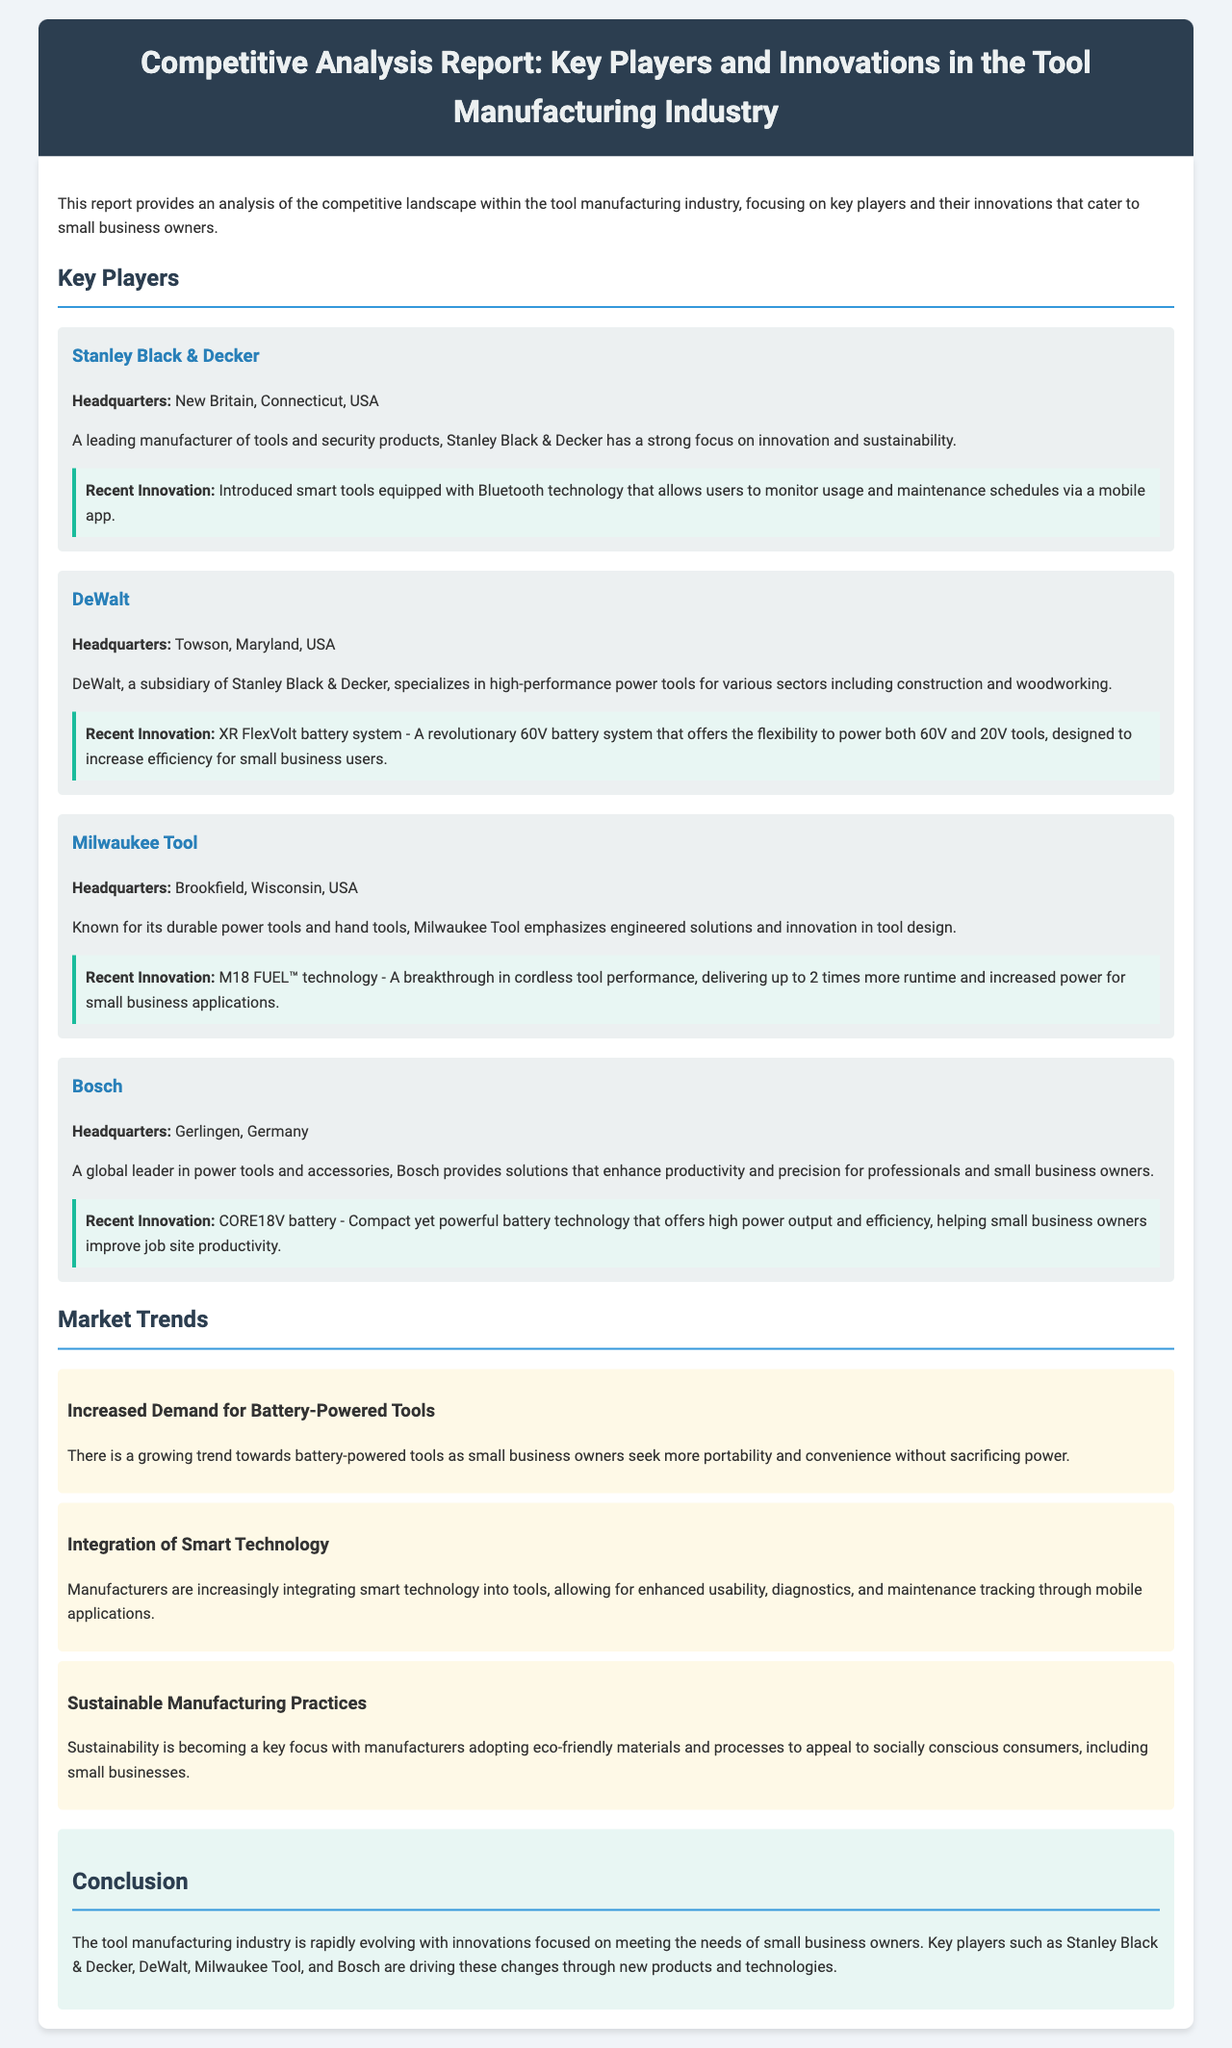what is the headquarters of Stanley Black & Decker? The headquarters of Stanley Black & Decker is mentioned in the document.
Answer: New Britain, Connecticut, USA what recent innovation did DeWalt introduce? The document states the recent innovation introduced by DeWalt.
Answer: XR FlexVolt battery system which company has introduced M18 FUEL™ technology? The document provides information about various companies and their innovations.
Answer: Milwaukee Tool what is one of the main trends in the tool manufacturing industry? The document lists various market trends within the tool manufacturing industry.
Answer: Increased Demand for Battery-Powered Tools who are the key players mentioned in the report? The report explicitly lists the key players in the tool manufacturing industry.
Answer: Stanley Black & Decker, DeWalt, Milwaukee Tool, Bosch what focus is becoming a key trend among manufacturers? The document highlights important market trends in the industry.
Answer: Sustainable Manufacturing Practices 